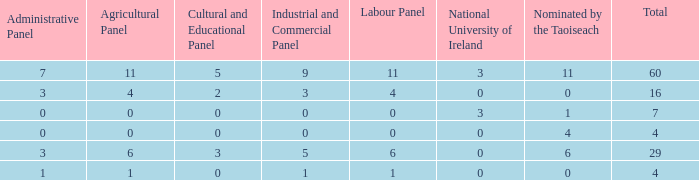What is the total number of agriculatural panels of the composition with more than 3 National Universities of Ireland? 0.0. Could you parse the entire table as a dict? {'header': ['Administrative Panel', 'Agricultural Panel', 'Cultural and Educational Panel', 'Industrial and Commercial Panel', 'Labour Panel', 'National University of Ireland', 'Nominated by the Taoiseach', 'Total'], 'rows': [['7', '11', '5', '9', '11', '3', '11', '60'], ['3', '4', '2', '3', '4', '0', '0', '16'], ['0', '0', '0', '0', '0', '3', '1', '7'], ['0', '0', '0', '0', '0', '0', '4', '4'], ['3', '6', '3', '5', '6', '0', '6', '29'], ['1', '1', '0', '1', '1', '0', '0', '4']]} 